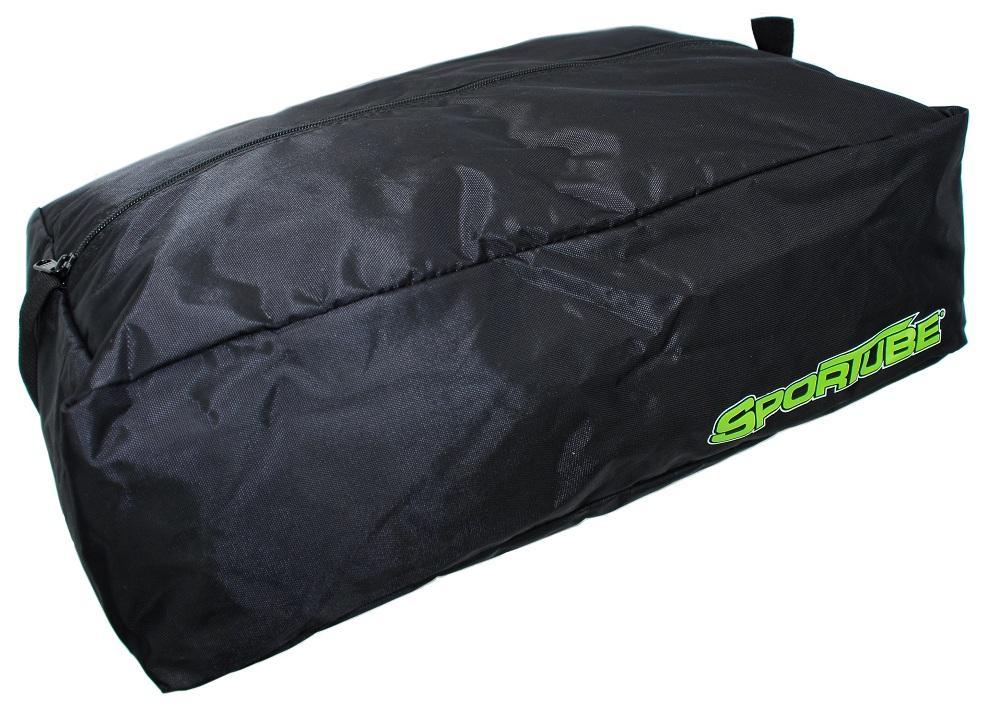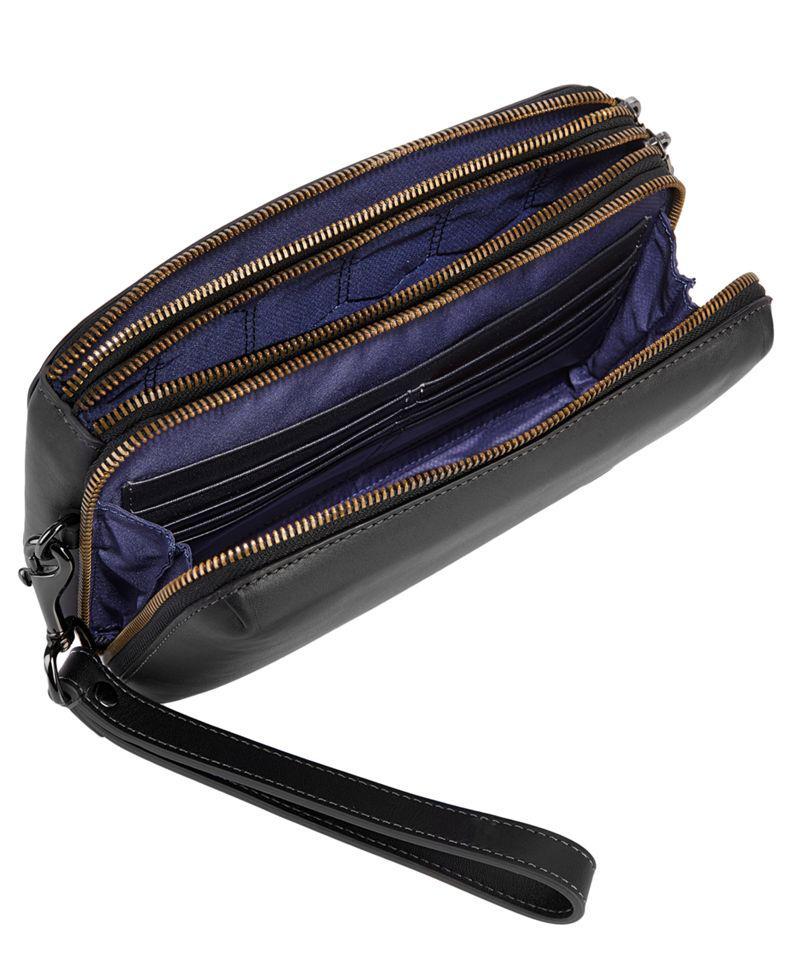The first image is the image on the left, the second image is the image on the right. Examine the images to the left and right. Is the description "A pouch is unzipped  and open in one of the images." accurate? Answer yes or no. Yes. The first image is the image on the left, the second image is the image on the right. Assess this claim about the two images: "One bag is unzipped.". Correct or not? Answer yes or no. Yes. 